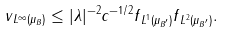<formula> <loc_0><loc_0><loc_500><loc_500>\| v \| _ { L ^ { \infty } ( \mu _ { B } ) } \leq | \lambda | ^ { - 2 } c ^ { - 1 / 2 } \| f \| _ { L ^ { 1 } ( \mu _ { B ^ { \prime } } ) } \| f \| _ { L ^ { 2 } ( \mu _ { B ^ { \prime } } ) } .</formula> 